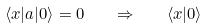<formula> <loc_0><loc_0><loc_500><loc_500>\langle x | a | 0 \rangle = 0 \quad \Rightarrow \quad \langle x | 0 \rangle</formula> 